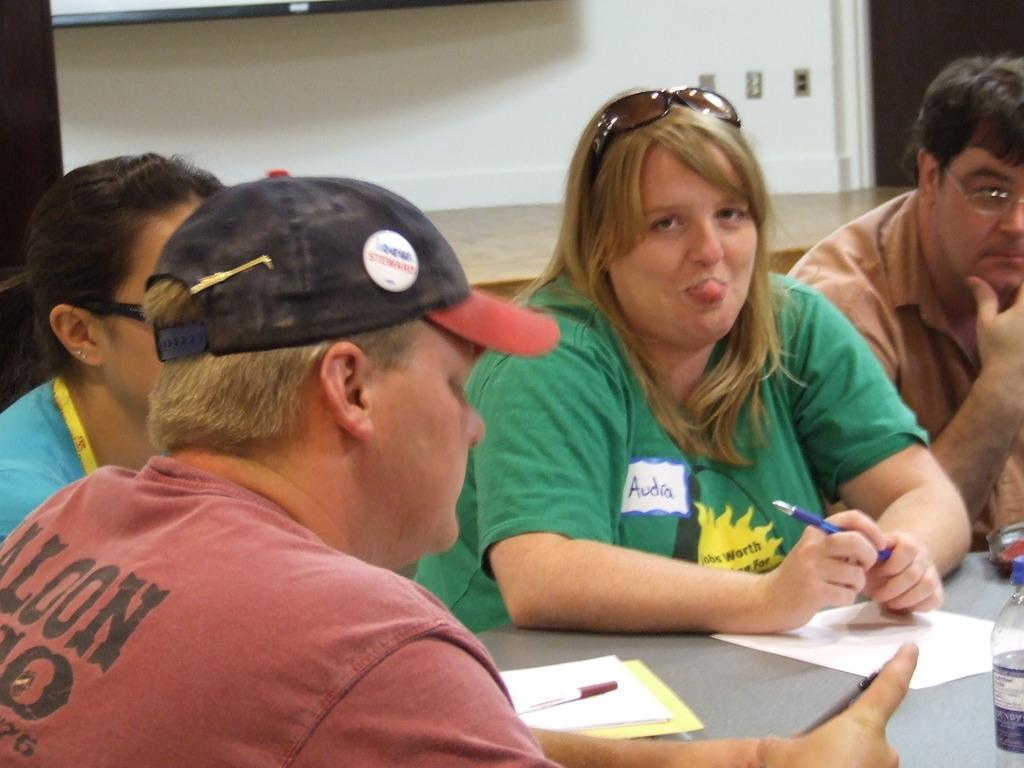How would you summarize this image in a sentence or two? In this image I can see there are few persons visible in front of the table , on the table I can see papers and pens and bottle and woman holding a pen in the middle ,at the top I can see the wall ,in front of the wall there is a table. 